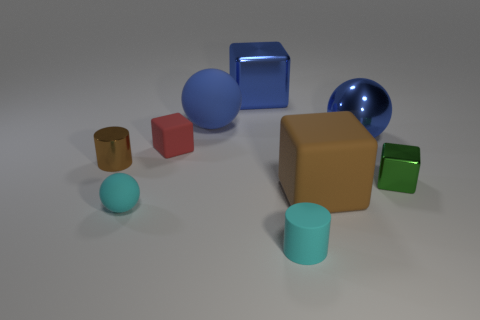Subtract all large blue matte spheres. How many spheres are left? 2 Subtract all green cubes. How many cubes are left? 3 Subtract 1 blocks. How many blocks are left? 3 Add 1 big gray metal cubes. How many objects exist? 10 Subtract all cylinders. How many objects are left? 7 Subtract all yellow balls. Subtract all blue cylinders. How many balls are left? 3 Subtract all gray objects. Subtract all red cubes. How many objects are left? 8 Add 5 big brown objects. How many big brown objects are left? 6 Add 3 cubes. How many cubes exist? 7 Subtract 0 green spheres. How many objects are left? 9 